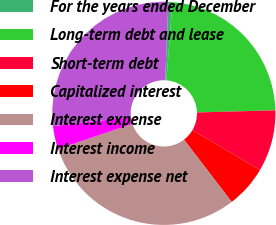Convert chart. <chart><loc_0><loc_0><loc_500><loc_500><pie_chart><fcel>For the years ended December<fcel>Long-term debt and lease<fcel>Short-term debt<fcel>Capitalized interest<fcel>Interest expense<fcel>Interest income<fcel>Interest expense net<nl><fcel>0.58%<fcel>23.34%<fcel>8.9%<fcel>6.13%<fcel>30.24%<fcel>3.35%<fcel>27.47%<nl></chart> 